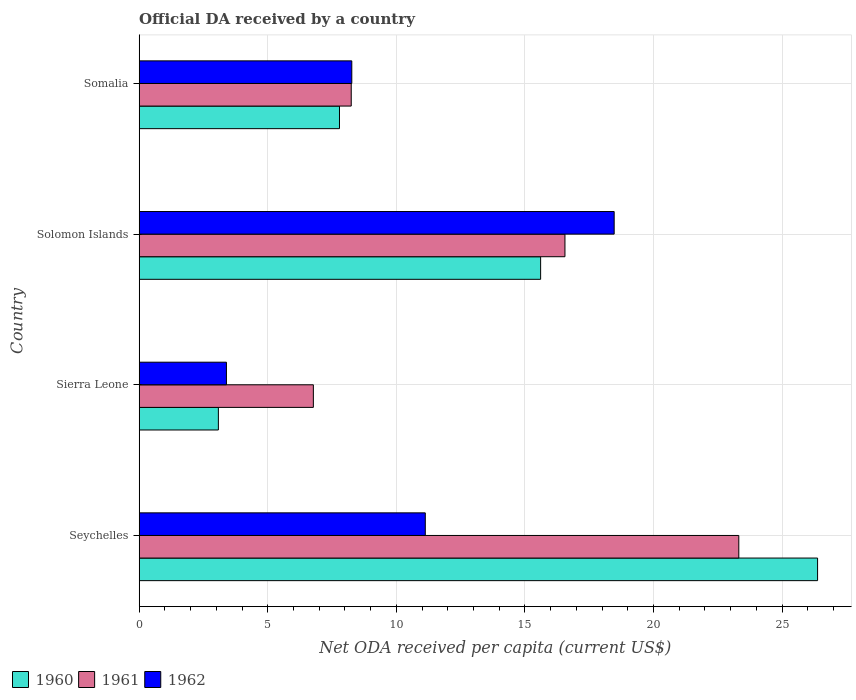How many different coloured bars are there?
Ensure brevity in your answer.  3. What is the label of the 4th group of bars from the top?
Keep it short and to the point. Seychelles. In how many cases, is the number of bars for a given country not equal to the number of legend labels?
Your answer should be compact. 0. What is the ODA received in in 1961 in Somalia?
Make the answer very short. 8.25. Across all countries, what is the maximum ODA received in in 1960?
Provide a short and direct response. 26.38. Across all countries, what is the minimum ODA received in in 1961?
Make the answer very short. 6.77. In which country was the ODA received in in 1961 maximum?
Give a very brief answer. Seychelles. In which country was the ODA received in in 1960 minimum?
Provide a succinct answer. Sierra Leone. What is the total ODA received in in 1961 in the graph?
Offer a terse response. 54.89. What is the difference between the ODA received in in 1961 in Seychelles and that in Somalia?
Provide a succinct answer. 15.07. What is the difference between the ODA received in in 1962 in Solomon Islands and the ODA received in in 1961 in Somalia?
Keep it short and to the point. 10.22. What is the average ODA received in in 1961 per country?
Give a very brief answer. 13.72. What is the difference between the ODA received in in 1960 and ODA received in in 1961 in Solomon Islands?
Provide a short and direct response. -0.95. What is the ratio of the ODA received in in 1961 in Seychelles to that in Somalia?
Your response must be concise. 2.83. Is the ODA received in in 1961 in Sierra Leone less than that in Somalia?
Provide a succinct answer. Yes. What is the difference between the highest and the second highest ODA received in in 1962?
Your answer should be compact. 7.34. What is the difference between the highest and the lowest ODA received in in 1962?
Provide a short and direct response. 15.08. Is the sum of the ODA received in in 1961 in Sierra Leone and Somalia greater than the maximum ODA received in in 1962 across all countries?
Provide a short and direct response. No. What does the 1st bar from the bottom in Somalia represents?
Your answer should be compact. 1960. Is it the case that in every country, the sum of the ODA received in in 1960 and ODA received in in 1962 is greater than the ODA received in in 1961?
Your response must be concise. No. Where does the legend appear in the graph?
Offer a terse response. Bottom left. How many legend labels are there?
Your answer should be compact. 3. How are the legend labels stacked?
Your response must be concise. Horizontal. What is the title of the graph?
Your answer should be very brief. Official DA received by a country. What is the label or title of the X-axis?
Provide a short and direct response. Net ODA received per capita (current US$). What is the Net ODA received per capita (current US$) in 1960 in Seychelles?
Offer a terse response. 26.38. What is the Net ODA received per capita (current US$) in 1961 in Seychelles?
Keep it short and to the point. 23.32. What is the Net ODA received per capita (current US$) in 1962 in Seychelles?
Provide a short and direct response. 11.13. What is the Net ODA received per capita (current US$) of 1960 in Sierra Leone?
Give a very brief answer. 3.08. What is the Net ODA received per capita (current US$) of 1961 in Sierra Leone?
Make the answer very short. 6.77. What is the Net ODA received per capita (current US$) in 1962 in Sierra Leone?
Provide a short and direct response. 3.39. What is the Net ODA received per capita (current US$) in 1960 in Solomon Islands?
Keep it short and to the point. 15.61. What is the Net ODA received per capita (current US$) in 1961 in Solomon Islands?
Ensure brevity in your answer.  16.56. What is the Net ODA received per capita (current US$) in 1962 in Solomon Islands?
Keep it short and to the point. 18.47. What is the Net ODA received per capita (current US$) of 1960 in Somalia?
Provide a short and direct response. 7.79. What is the Net ODA received per capita (current US$) of 1961 in Somalia?
Offer a very short reply. 8.25. What is the Net ODA received per capita (current US$) in 1962 in Somalia?
Your response must be concise. 8.27. Across all countries, what is the maximum Net ODA received per capita (current US$) in 1960?
Make the answer very short. 26.38. Across all countries, what is the maximum Net ODA received per capita (current US$) in 1961?
Give a very brief answer. 23.32. Across all countries, what is the maximum Net ODA received per capita (current US$) of 1962?
Offer a terse response. 18.47. Across all countries, what is the minimum Net ODA received per capita (current US$) in 1960?
Offer a very short reply. 3.08. Across all countries, what is the minimum Net ODA received per capita (current US$) in 1961?
Make the answer very short. 6.77. Across all countries, what is the minimum Net ODA received per capita (current US$) in 1962?
Your answer should be very brief. 3.39. What is the total Net ODA received per capita (current US$) of 1960 in the graph?
Make the answer very short. 52.86. What is the total Net ODA received per capita (current US$) in 1961 in the graph?
Ensure brevity in your answer.  54.89. What is the total Net ODA received per capita (current US$) of 1962 in the graph?
Provide a succinct answer. 41.26. What is the difference between the Net ODA received per capita (current US$) of 1960 in Seychelles and that in Sierra Leone?
Your answer should be compact. 23.3. What is the difference between the Net ODA received per capita (current US$) of 1961 in Seychelles and that in Sierra Leone?
Keep it short and to the point. 16.54. What is the difference between the Net ODA received per capita (current US$) in 1962 in Seychelles and that in Sierra Leone?
Offer a terse response. 7.73. What is the difference between the Net ODA received per capita (current US$) in 1960 in Seychelles and that in Solomon Islands?
Your response must be concise. 10.77. What is the difference between the Net ODA received per capita (current US$) of 1961 in Seychelles and that in Solomon Islands?
Offer a terse response. 6.76. What is the difference between the Net ODA received per capita (current US$) of 1962 in Seychelles and that in Solomon Islands?
Give a very brief answer. -7.34. What is the difference between the Net ODA received per capita (current US$) of 1960 in Seychelles and that in Somalia?
Your answer should be compact. 18.59. What is the difference between the Net ODA received per capita (current US$) of 1961 in Seychelles and that in Somalia?
Your answer should be compact. 15.07. What is the difference between the Net ODA received per capita (current US$) of 1962 in Seychelles and that in Somalia?
Your answer should be compact. 2.86. What is the difference between the Net ODA received per capita (current US$) of 1960 in Sierra Leone and that in Solomon Islands?
Keep it short and to the point. -12.53. What is the difference between the Net ODA received per capita (current US$) of 1961 in Sierra Leone and that in Solomon Islands?
Offer a very short reply. -9.78. What is the difference between the Net ODA received per capita (current US$) of 1962 in Sierra Leone and that in Solomon Islands?
Your answer should be very brief. -15.08. What is the difference between the Net ODA received per capita (current US$) in 1960 in Sierra Leone and that in Somalia?
Your response must be concise. -4.71. What is the difference between the Net ODA received per capita (current US$) in 1961 in Sierra Leone and that in Somalia?
Your response must be concise. -1.47. What is the difference between the Net ODA received per capita (current US$) in 1962 in Sierra Leone and that in Somalia?
Provide a short and direct response. -4.87. What is the difference between the Net ODA received per capita (current US$) in 1960 in Solomon Islands and that in Somalia?
Give a very brief answer. 7.82. What is the difference between the Net ODA received per capita (current US$) of 1961 in Solomon Islands and that in Somalia?
Your answer should be very brief. 8.31. What is the difference between the Net ODA received per capita (current US$) in 1962 in Solomon Islands and that in Somalia?
Provide a short and direct response. 10.2. What is the difference between the Net ODA received per capita (current US$) in 1960 in Seychelles and the Net ODA received per capita (current US$) in 1961 in Sierra Leone?
Provide a succinct answer. 19.61. What is the difference between the Net ODA received per capita (current US$) in 1960 in Seychelles and the Net ODA received per capita (current US$) in 1962 in Sierra Leone?
Provide a succinct answer. 22.99. What is the difference between the Net ODA received per capita (current US$) of 1961 in Seychelles and the Net ODA received per capita (current US$) of 1962 in Sierra Leone?
Offer a very short reply. 19.92. What is the difference between the Net ODA received per capita (current US$) of 1960 in Seychelles and the Net ODA received per capita (current US$) of 1961 in Solomon Islands?
Ensure brevity in your answer.  9.82. What is the difference between the Net ODA received per capita (current US$) in 1960 in Seychelles and the Net ODA received per capita (current US$) in 1962 in Solomon Islands?
Offer a very short reply. 7.91. What is the difference between the Net ODA received per capita (current US$) in 1961 in Seychelles and the Net ODA received per capita (current US$) in 1962 in Solomon Islands?
Give a very brief answer. 4.85. What is the difference between the Net ODA received per capita (current US$) of 1960 in Seychelles and the Net ODA received per capita (current US$) of 1961 in Somalia?
Keep it short and to the point. 18.13. What is the difference between the Net ODA received per capita (current US$) in 1960 in Seychelles and the Net ODA received per capita (current US$) in 1962 in Somalia?
Offer a terse response. 18.11. What is the difference between the Net ODA received per capita (current US$) of 1961 in Seychelles and the Net ODA received per capita (current US$) of 1962 in Somalia?
Keep it short and to the point. 15.05. What is the difference between the Net ODA received per capita (current US$) in 1960 in Sierra Leone and the Net ODA received per capita (current US$) in 1961 in Solomon Islands?
Make the answer very short. -13.48. What is the difference between the Net ODA received per capita (current US$) of 1960 in Sierra Leone and the Net ODA received per capita (current US$) of 1962 in Solomon Islands?
Make the answer very short. -15.39. What is the difference between the Net ODA received per capita (current US$) in 1961 in Sierra Leone and the Net ODA received per capita (current US$) in 1962 in Solomon Islands?
Your answer should be very brief. -11.7. What is the difference between the Net ODA received per capita (current US$) of 1960 in Sierra Leone and the Net ODA received per capita (current US$) of 1961 in Somalia?
Provide a short and direct response. -5.17. What is the difference between the Net ODA received per capita (current US$) in 1960 in Sierra Leone and the Net ODA received per capita (current US$) in 1962 in Somalia?
Provide a short and direct response. -5.19. What is the difference between the Net ODA received per capita (current US$) of 1961 in Sierra Leone and the Net ODA received per capita (current US$) of 1962 in Somalia?
Keep it short and to the point. -1.49. What is the difference between the Net ODA received per capita (current US$) of 1960 in Solomon Islands and the Net ODA received per capita (current US$) of 1961 in Somalia?
Your answer should be compact. 7.36. What is the difference between the Net ODA received per capita (current US$) in 1960 in Solomon Islands and the Net ODA received per capita (current US$) in 1962 in Somalia?
Provide a short and direct response. 7.34. What is the difference between the Net ODA received per capita (current US$) of 1961 in Solomon Islands and the Net ODA received per capita (current US$) of 1962 in Somalia?
Ensure brevity in your answer.  8.29. What is the average Net ODA received per capita (current US$) in 1960 per country?
Your answer should be compact. 13.21. What is the average Net ODA received per capita (current US$) of 1961 per country?
Make the answer very short. 13.72. What is the average Net ODA received per capita (current US$) in 1962 per country?
Your response must be concise. 10.31. What is the difference between the Net ODA received per capita (current US$) in 1960 and Net ODA received per capita (current US$) in 1961 in Seychelles?
Give a very brief answer. 3.06. What is the difference between the Net ODA received per capita (current US$) in 1960 and Net ODA received per capita (current US$) in 1962 in Seychelles?
Give a very brief answer. 15.25. What is the difference between the Net ODA received per capita (current US$) in 1961 and Net ODA received per capita (current US$) in 1962 in Seychelles?
Ensure brevity in your answer.  12.19. What is the difference between the Net ODA received per capita (current US$) of 1960 and Net ODA received per capita (current US$) of 1961 in Sierra Leone?
Provide a short and direct response. -3.69. What is the difference between the Net ODA received per capita (current US$) in 1960 and Net ODA received per capita (current US$) in 1962 in Sierra Leone?
Provide a short and direct response. -0.31. What is the difference between the Net ODA received per capita (current US$) of 1961 and Net ODA received per capita (current US$) of 1962 in Sierra Leone?
Your answer should be compact. 3.38. What is the difference between the Net ODA received per capita (current US$) in 1960 and Net ODA received per capita (current US$) in 1961 in Solomon Islands?
Your answer should be very brief. -0.95. What is the difference between the Net ODA received per capita (current US$) of 1960 and Net ODA received per capita (current US$) of 1962 in Solomon Islands?
Provide a succinct answer. -2.86. What is the difference between the Net ODA received per capita (current US$) in 1961 and Net ODA received per capita (current US$) in 1962 in Solomon Islands?
Keep it short and to the point. -1.91. What is the difference between the Net ODA received per capita (current US$) in 1960 and Net ODA received per capita (current US$) in 1961 in Somalia?
Provide a short and direct response. -0.46. What is the difference between the Net ODA received per capita (current US$) of 1960 and Net ODA received per capita (current US$) of 1962 in Somalia?
Provide a succinct answer. -0.48. What is the difference between the Net ODA received per capita (current US$) of 1961 and Net ODA received per capita (current US$) of 1962 in Somalia?
Ensure brevity in your answer.  -0.02. What is the ratio of the Net ODA received per capita (current US$) of 1960 in Seychelles to that in Sierra Leone?
Provide a short and direct response. 8.56. What is the ratio of the Net ODA received per capita (current US$) of 1961 in Seychelles to that in Sierra Leone?
Your response must be concise. 3.44. What is the ratio of the Net ODA received per capita (current US$) in 1962 in Seychelles to that in Sierra Leone?
Ensure brevity in your answer.  3.28. What is the ratio of the Net ODA received per capita (current US$) in 1960 in Seychelles to that in Solomon Islands?
Provide a succinct answer. 1.69. What is the ratio of the Net ODA received per capita (current US$) in 1961 in Seychelles to that in Solomon Islands?
Offer a terse response. 1.41. What is the ratio of the Net ODA received per capita (current US$) in 1962 in Seychelles to that in Solomon Islands?
Offer a terse response. 0.6. What is the ratio of the Net ODA received per capita (current US$) in 1960 in Seychelles to that in Somalia?
Your answer should be very brief. 3.39. What is the ratio of the Net ODA received per capita (current US$) in 1961 in Seychelles to that in Somalia?
Give a very brief answer. 2.83. What is the ratio of the Net ODA received per capita (current US$) in 1962 in Seychelles to that in Somalia?
Ensure brevity in your answer.  1.35. What is the ratio of the Net ODA received per capita (current US$) of 1960 in Sierra Leone to that in Solomon Islands?
Your response must be concise. 0.2. What is the ratio of the Net ODA received per capita (current US$) of 1961 in Sierra Leone to that in Solomon Islands?
Your answer should be compact. 0.41. What is the ratio of the Net ODA received per capita (current US$) in 1962 in Sierra Leone to that in Solomon Islands?
Your answer should be very brief. 0.18. What is the ratio of the Net ODA received per capita (current US$) in 1960 in Sierra Leone to that in Somalia?
Ensure brevity in your answer.  0.4. What is the ratio of the Net ODA received per capita (current US$) of 1961 in Sierra Leone to that in Somalia?
Keep it short and to the point. 0.82. What is the ratio of the Net ODA received per capita (current US$) of 1962 in Sierra Leone to that in Somalia?
Your response must be concise. 0.41. What is the ratio of the Net ODA received per capita (current US$) of 1960 in Solomon Islands to that in Somalia?
Your answer should be compact. 2. What is the ratio of the Net ODA received per capita (current US$) in 1961 in Solomon Islands to that in Somalia?
Offer a terse response. 2.01. What is the ratio of the Net ODA received per capita (current US$) of 1962 in Solomon Islands to that in Somalia?
Your response must be concise. 2.23. What is the difference between the highest and the second highest Net ODA received per capita (current US$) in 1960?
Provide a short and direct response. 10.77. What is the difference between the highest and the second highest Net ODA received per capita (current US$) of 1961?
Your response must be concise. 6.76. What is the difference between the highest and the second highest Net ODA received per capita (current US$) in 1962?
Your response must be concise. 7.34. What is the difference between the highest and the lowest Net ODA received per capita (current US$) of 1960?
Offer a terse response. 23.3. What is the difference between the highest and the lowest Net ODA received per capita (current US$) in 1961?
Ensure brevity in your answer.  16.54. What is the difference between the highest and the lowest Net ODA received per capita (current US$) in 1962?
Keep it short and to the point. 15.08. 